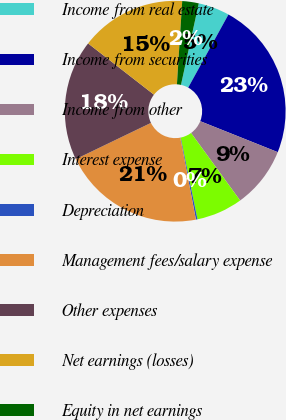Convert chart. <chart><loc_0><loc_0><loc_500><loc_500><pie_chart><fcel>Income from real estate<fcel>Income from securities<fcel>Income from other<fcel>Interest expense<fcel>Depreciation<fcel>Management fees/salary expense<fcel>Other expenses<fcel>Net earnings (losses)<fcel>Equity in net earnings<nl><fcel>4.59%<fcel>23.04%<fcel>8.95%<fcel>6.77%<fcel>0.23%<fcel>20.86%<fcel>17.67%<fcel>15.49%<fcel>2.41%<nl></chart> 